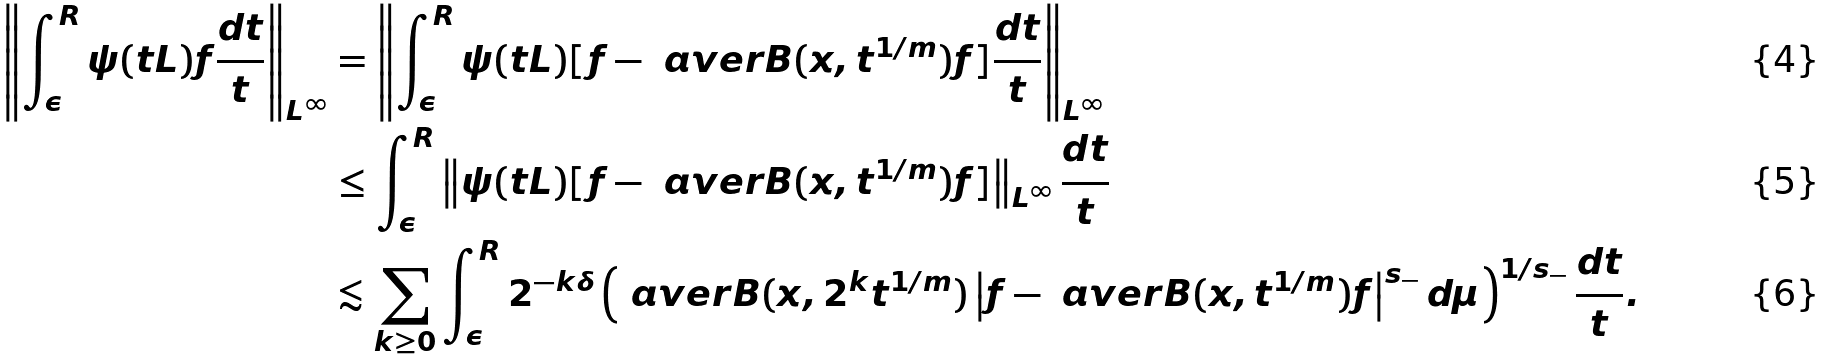Convert formula to latex. <formula><loc_0><loc_0><loc_500><loc_500>\left \| \int _ { \epsilon } ^ { R } \psi ( t L ) f \frac { d t } { t } \right \| _ { L ^ { \infty } } & = \left \| \int _ { \epsilon } ^ { R } \psi ( t L ) [ f - \ a v e r { B ( x , t ^ { 1 / m } ) } f ] \frac { d t } { t } \right \| _ { L ^ { \infty } } \\ & \leq \int _ { \epsilon } ^ { R } \left \| \psi ( t L ) [ f - \ a v e r { B ( x , t ^ { 1 / m } ) } f ] \right \| _ { L ^ { \infty } } \frac { d t } { t } \\ & \lesssim \sum _ { k \geq 0 } \int _ { \epsilon } ^ { R } 2 ^ { - k \delta } \left ( \ a v e r { B ( x , 2 ^ { k } t ^ { 1 / m } ) } \left | f - \ a v e r { B ( x , t ^ { 1 / m } ) } f \right | ^ { s _ { - } } d \mu \right ) ^ { 1 / s _ { - } } \frac { d t } { t } .</formula> 